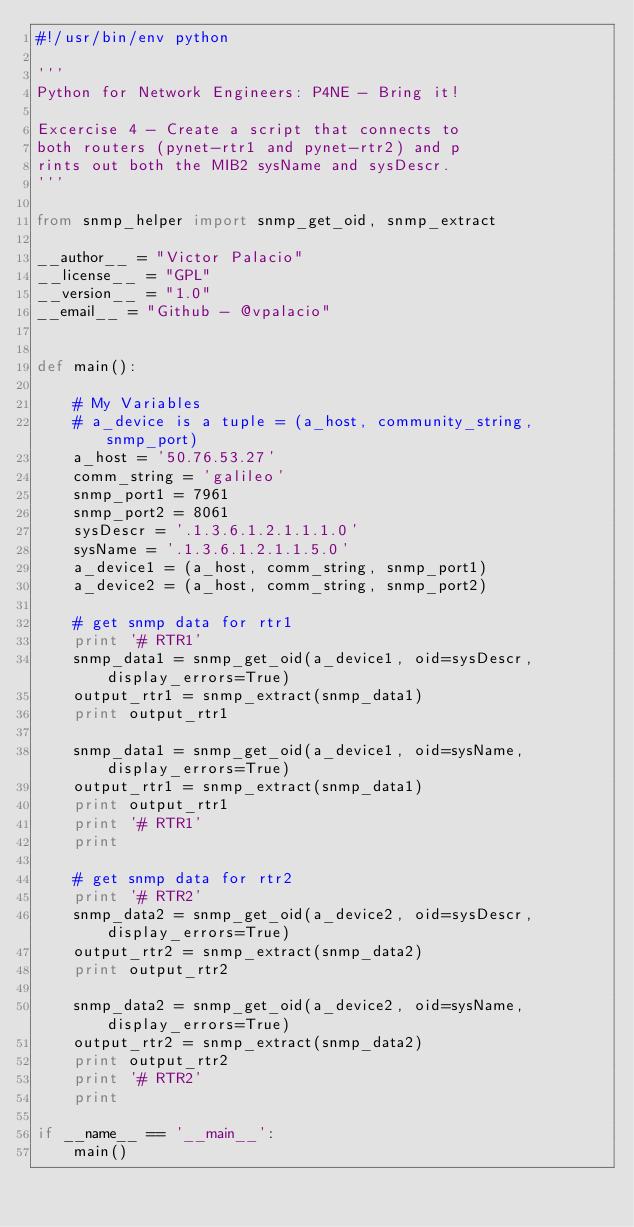<code> <loc_0><loc_0><loc_500><loc_500><_Python_>#!/usr/bin/env python

'''
Python for Network Engineers: P4NE - Bring it!

Excercise 4 - Create a script that connects to 
both routers (pynet-rtr1 and pynet-rtr2) and p
rints out both the MIB2 sysName and sysDescr.
'''

from snmp_helper import snmp_get_oid, snmp_extract

__author__ = "Victor Palacio"
__license__ = "GPL"
__version__ = "1.0"
__email__ = "Github - @vpalacio"


def main():

    # My Variables
    # a_device is a tuple = (a_host, community_string, snmp_port)
    a_host = '50.76.53.27'
    comm_string = 'galileo'
    snmp_port1 = 7961
    snmp_port2 = 8061
    sysDescr = '.1.3.6.1.2.1.1.1.0'
    sysName = '.1.3.6.1.2.1.1.5.0'
    a_device1 = (a_host, comm_string, snmp_port1)
    a_device2 = (a_host, comm_string, snmp_port2)

    # get snmp data for rtr1
    print '# RTR1'
    snmp_data1 = snmp_get_oid(a_device1, oid=sysDescr, display_errors=True)
    output_rtr1 = snmp_extract(snmp_data1)
    print output_rtr1

    snmp_data1 = snmp_get_oid(a_device1, oid=sysName, display_errors=True)
    output_rtr1 = snmp_extract(snmp_data1)
    print output_rtr1
    print '# RTR1'
    print

    # get snmp data for rtr2
    print '# RTR2'
    snmp_data2 = snmp_get_oid(a_device2, oid=sysDescr, display_errors=True)
    output_rtr2 = snmp_extract(snmp_data2)
    print output_rtr2

    snmp_data2 = snmp_get_oid(a_device2, oid=sysName, display_errors=True)
    output_rtr2 = snmp_extract(snmp_data2)
    print output_rtr2
    print '# RTR2'
    print

if __name__ == '__main__':
    main()
</code> 